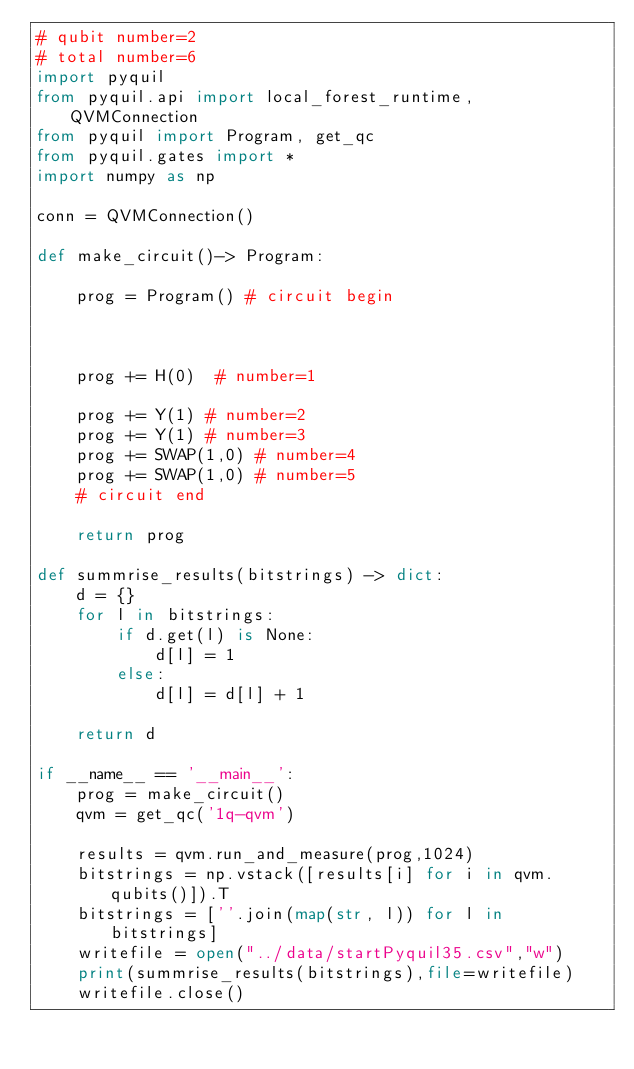<code> <loc_0><loc_0><loc_500><loc_500><_Python_># qubit number=2
# total number=6
import pyquil
from pyquil.api import local_forest_runtime, QVMConnection
from pyquil import Program, get_qc
from pyquil.gates import *
import numpy as np

conn = QVMConnection()

def make_circuit()-> Program:

    prog = Program() # circuit begin



    prog += H(0)  # number=1

    prog += Y(1) # number=2
    prog += Y(1) # number=3
    prog += SWAP(1,0) # number=4
    prog += SWAP(1,0) # number=5
    # circuit end

    return prog

def summrise_results(bitstrings) -> dict:
    d = {}
    for l in bitstrings:
        if d.get(l) is None:
            d[l] = 1
        else:
            d[l] = d[l] + 1

    return d

if __name__ == '__main__':
    prog = make_circuit()
    qvm = get_qc('1q-qvm')

    results = qvm.run_and_measure(prog,1024)
    bitstrings = np.vstack([results[i] for i in qvm.qubits()]).T
    bitstrings = [''.join(map(str, l)) for l in bitstrings]
    writefile = open("../data/startPyquil35.csv","w")
    print(summrise_results(bitstrings),file=writefile)
    writefile.close()

</code> 